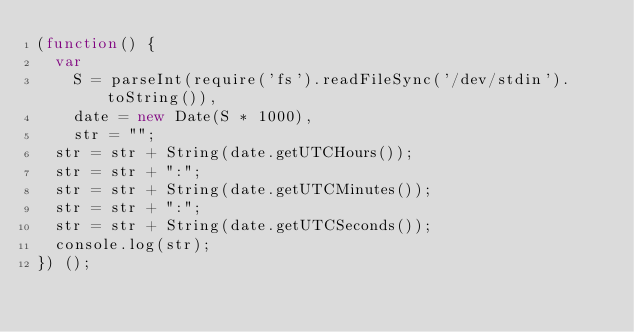Convert code to text. <code><loc_0><loc_0><loc_500><loc_500><_JavaScript_>(function() {
	var
		S = parseInt(require('fs').readFileSync('/dev/stdin').toString()),
		date = new Date(S * 1000),
		str = "";
	str = str + String(date.getUTCHours());
	str = str + ":";
	str = str + String(date.getUTCMinutes());
	str = str + ":";
	str = str + String(date.getUTCSeconds());
	console.log(str);
}) ();</code> 